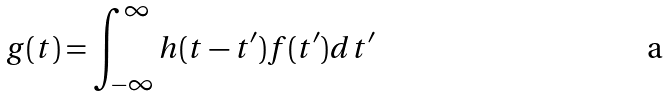<formula> <loc_0><loc_0><loc_500><loc_500>g ( t ) = \int _ { - \infty } ^ { \infty } h ( t - t ^ { \prime } ) f ( t ^ { \prime } ) d t ^ { \prime }</formula> 